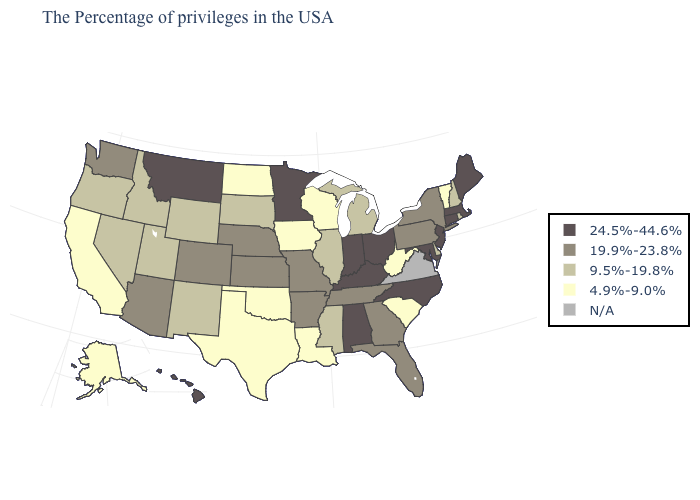What is the highest value in the USA?
Keep it brief. 24.5%-44.6%. What is the value of Florida?
Be succinct. 19.9%-23.8%. Which states have the lowest value in the USA?
Answer briefly. Vermont, South Carolina, West Virginia, Wisconsin, Louisiana, Iowa, Oklahoma, Texas, North Dakota, California, Alaska. Among the states that border Utah , does Arizona have the lowest value?
Write a very short answer. No. Among the states that border North Dakota , does South Dakota have the lowest value?
Keep it brief. Yes. What is the lowest value in the USA?
Quick response, please. 4.9%-9.0%. Does the map have missing data?
Give a very brief answer. Yes. Name the states that have a value in the range 19.9%-23.8%?
Answer briefly. New York, Pennsylvania, Florida, Georgia, Tennessee, Missouri, Arkansas, Kansas, Nebraska, Colorado, Arizona, Washington. What is the value of New Hampshire?
Answer briefly. 9.5%-19.8%. Name the states that have a value in the range 19.9%-23.8%?
Concise answer only. New York, Pennsylvania, Florida, Georgia, Tennessee, Missouri, Arkansas, Kansas, Nebraska, Colorado, Arizona, Washington. What is the value of North Dakota?
Answer briefly. 4.9%-9.0%. What is the lowest value in the USA?
Be succinct. 4.9%-9.0%. Is the legend a continuous bar?
Give a very brief answer. No. 